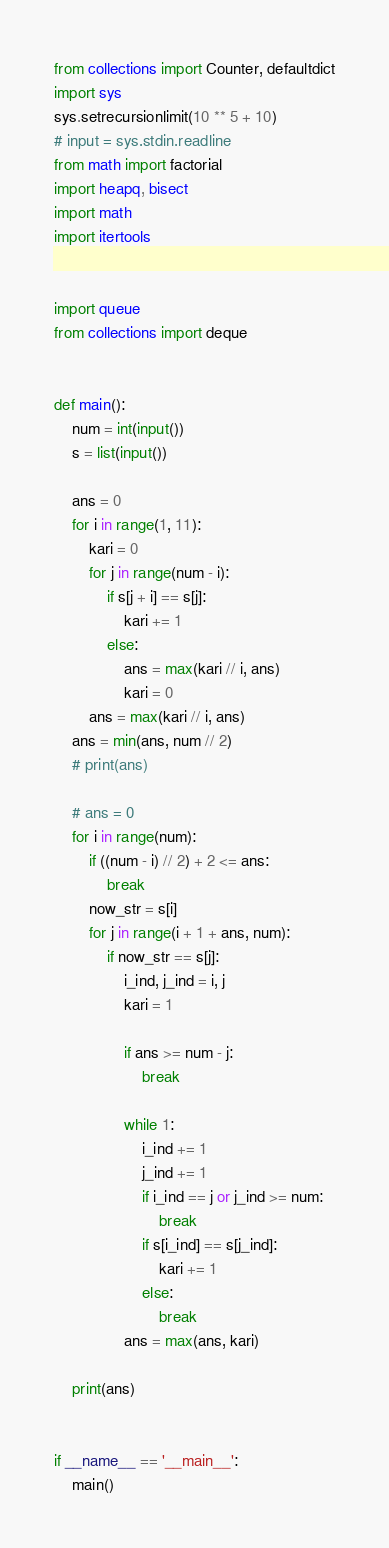Convert code to text. <code><loc_0><loc_0><loc_500><loc_500><_Python_>from collections import Counter, defaultdict
import sys
sys.setrecursionlimit(10 ** 5 + 10)
# input = sys.stdin.readline
from math import factorial
import heapq, bisect
import math
import itertools


import queue
from collections import deque


def main():
    num = int(input())
    s = list(input())

    ans = 0
    for i in range(1, 11):
        kari = 0
        for j in range(num - i):
            if s[j + i] == s[j]:
                kari += 1
            else:
                ans = max(kari // i, ans)
                kari = 0
        ans = max(kari // i, ans)
    ans = min(ans, num // 2)
    # print(ans)

    # ans = 0
    for i in range(num):
        if ((num - i) // 2) + 2 <= ans:
            break
        now_str = s[i]
        for j in range(i + 1 + ans, num):
            if now_str == s[j]:
                i_ind, j_ind = i, j
                kari = 1

                if ans >= num - j:
                    break

                while 1:
                    i_ind += 1
                    j_ind += 1
                    if i_ind == j or j_ind >= num:
                        break
                    if s[i_ind] == s[j_ind]:
                        kari += 1
                    else:
                        break
                ans = max(ans, kari)

    print(ans)


if __name__ == '__main__':
    main()
</code> 